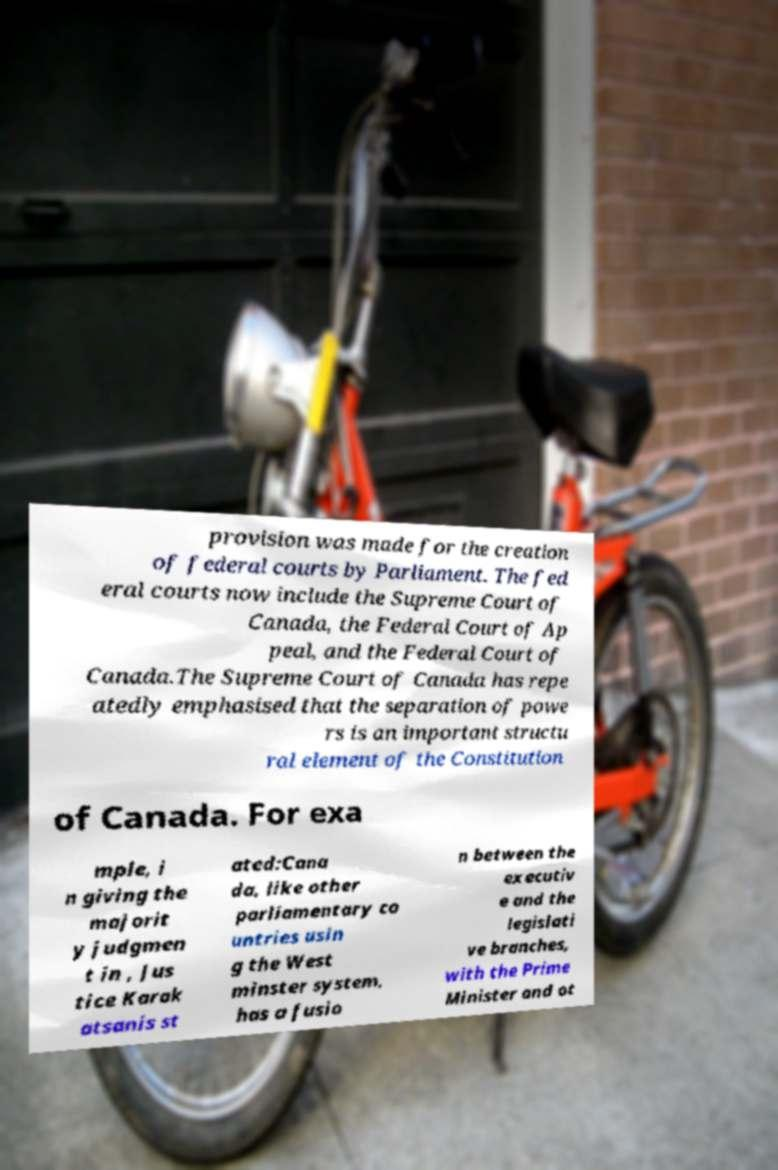Can you accurately transcribe the text from the provided image for me? provision was made for the creation of federal courts by Parliament. The fed eral courts now include the Supreme Court of Canada, the Federal Court of Ap peal, and the Federal Court of Canada.The Supreme Court of Canada has repe atedly emphasised that the separation of powe rs is an important structu ral element of the Constitution of Canada. For exa mple, i n giving the majorit y judgmen t in , Jus tice Karak atsanis st ated:Cana da, like other parliamentary co untries usin g the West minster system, has a fusio n between the executiv e and the legislati ve branches, with the Prime Minister and ot 